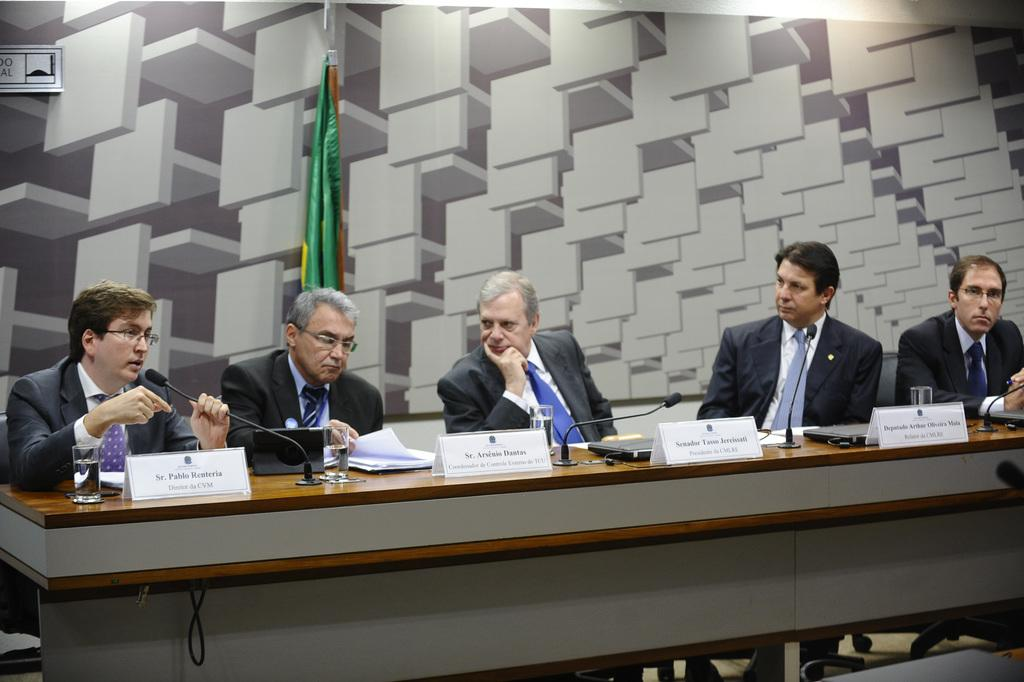How many persons are sitting in a row in the image? There are five persons sitting in a row in the image. What are the persons wearing? Each person is wearing a suit, tie, and white shirt. What is in front of the persons? There is a table in front of the persons. What can be found on the table? Name boards and glasses are present on the table. What can be seen in the background of the image? There is a flag and a wall in the background. How many bulbs are hanging from the arch in the image? There is no arch or bulbs present in the image. What type of test is being conducted in the image? There is no test being conducted in the image; it features five persons sitting in a row with a table in front of them. 